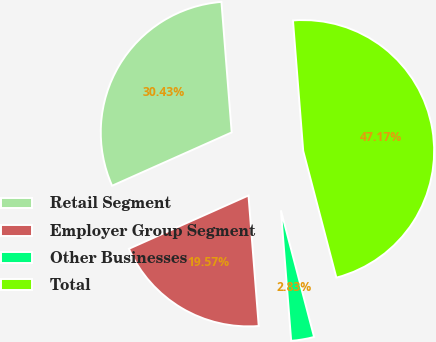Convert chart to OTSL. <chart><loc_0><loc_0><loc_500><loc_500><pie_chart><fcel>Retail Segment<fcel>Employer Group Segment<fcel>Other Businesses<fcel>Total<nl><fcel>30.43%<fcel>19.57%<fcel>2.83%<fcel>47.17%<nl></chart> 